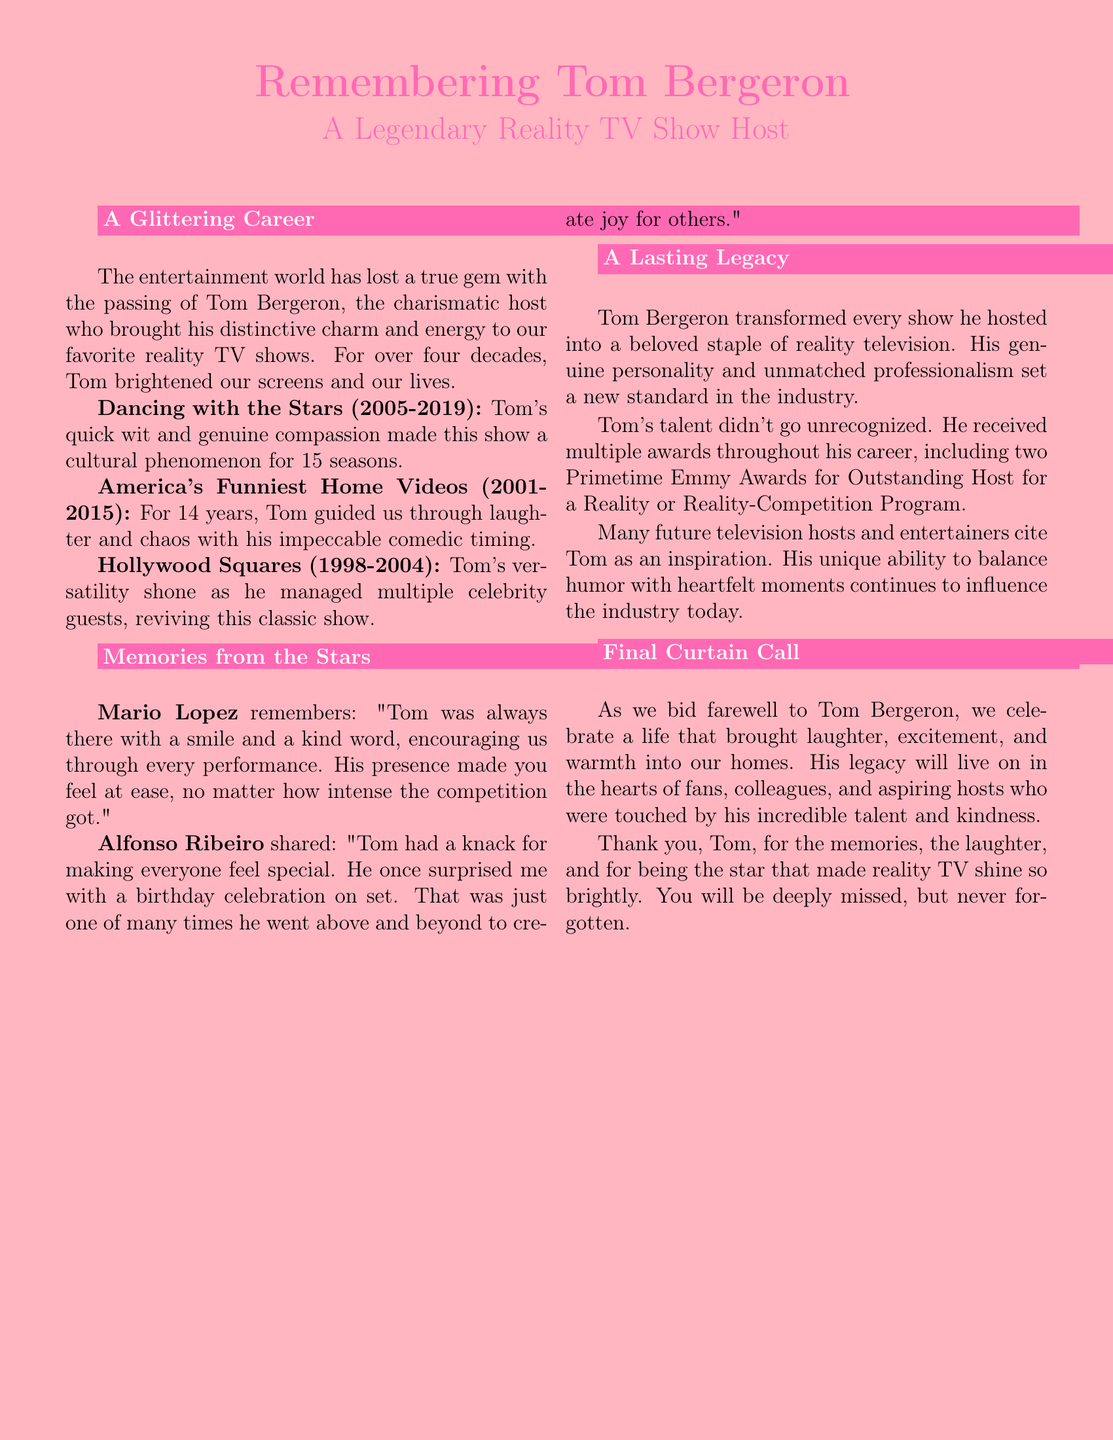What was the name of the legendary host? The document discusses Tom Bergeron, who is the subject of the obituary.
Answer: Tom Bergeron How many seasons did Tom host "Dancing with the Stars"? The document mentions that Tom hosted the show for 15 seasons.
Answer: 15 Which award did Tom receive twice during his career? The document states he won two Primetime Emmy Awards for Outstanding Host.
Answer: Primetime Emmy Awards Who shared a personal anecdote about a birthday celebration on set? The document includes a memory shared by Alfonso Ribeiro regarding a birthday celebration.
Answer: Alfonso Ribeiro In which year did Tom start hosting "America's Funniest Home Videos"? The document indicates that Tom began hosting the show in 2001.
Answer: 2001 What show did Tom host before "Dancing with the Stars"? The document lists "America's Funniest Home Videos" as Tom's previous show before "Dancing with the Stars".
Answer: America's Funniest Home Videos What is a key characteristic of Tom's hosting style mentioned in the document? The document describes his quick wit and genuine compassion as significant traits of his hosting.
Answer: Quick wit and genuine compassion How did Tom's career in reality TV impact future hosts? The document mentions that many future television hosts cite Tom as an inspiration.
Answer: Inspiration What was the tone of the final section of the obituary? The final section expresses a farewell tone while celebrating Tom's life and contributions.
Answer: Farewell and celebration 